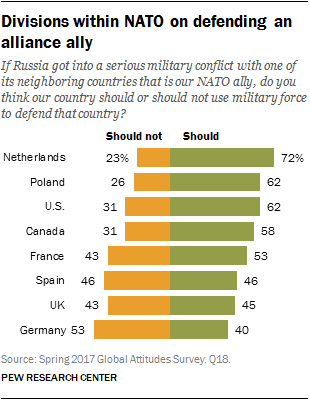Indicate a few pertinent items in this graphic. The smallest acceptable value of the Should bar is 40%. The ratio of orange bar occurrences with values 31 and 43 is 0.042361111... 